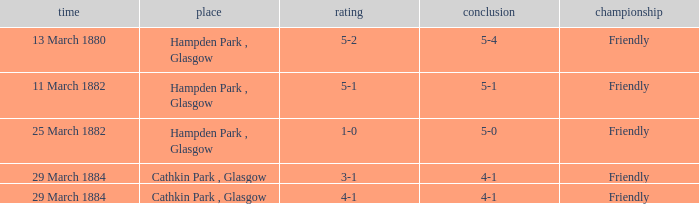Which item resulted in a score of 4-1? 3-1, 4-1. 